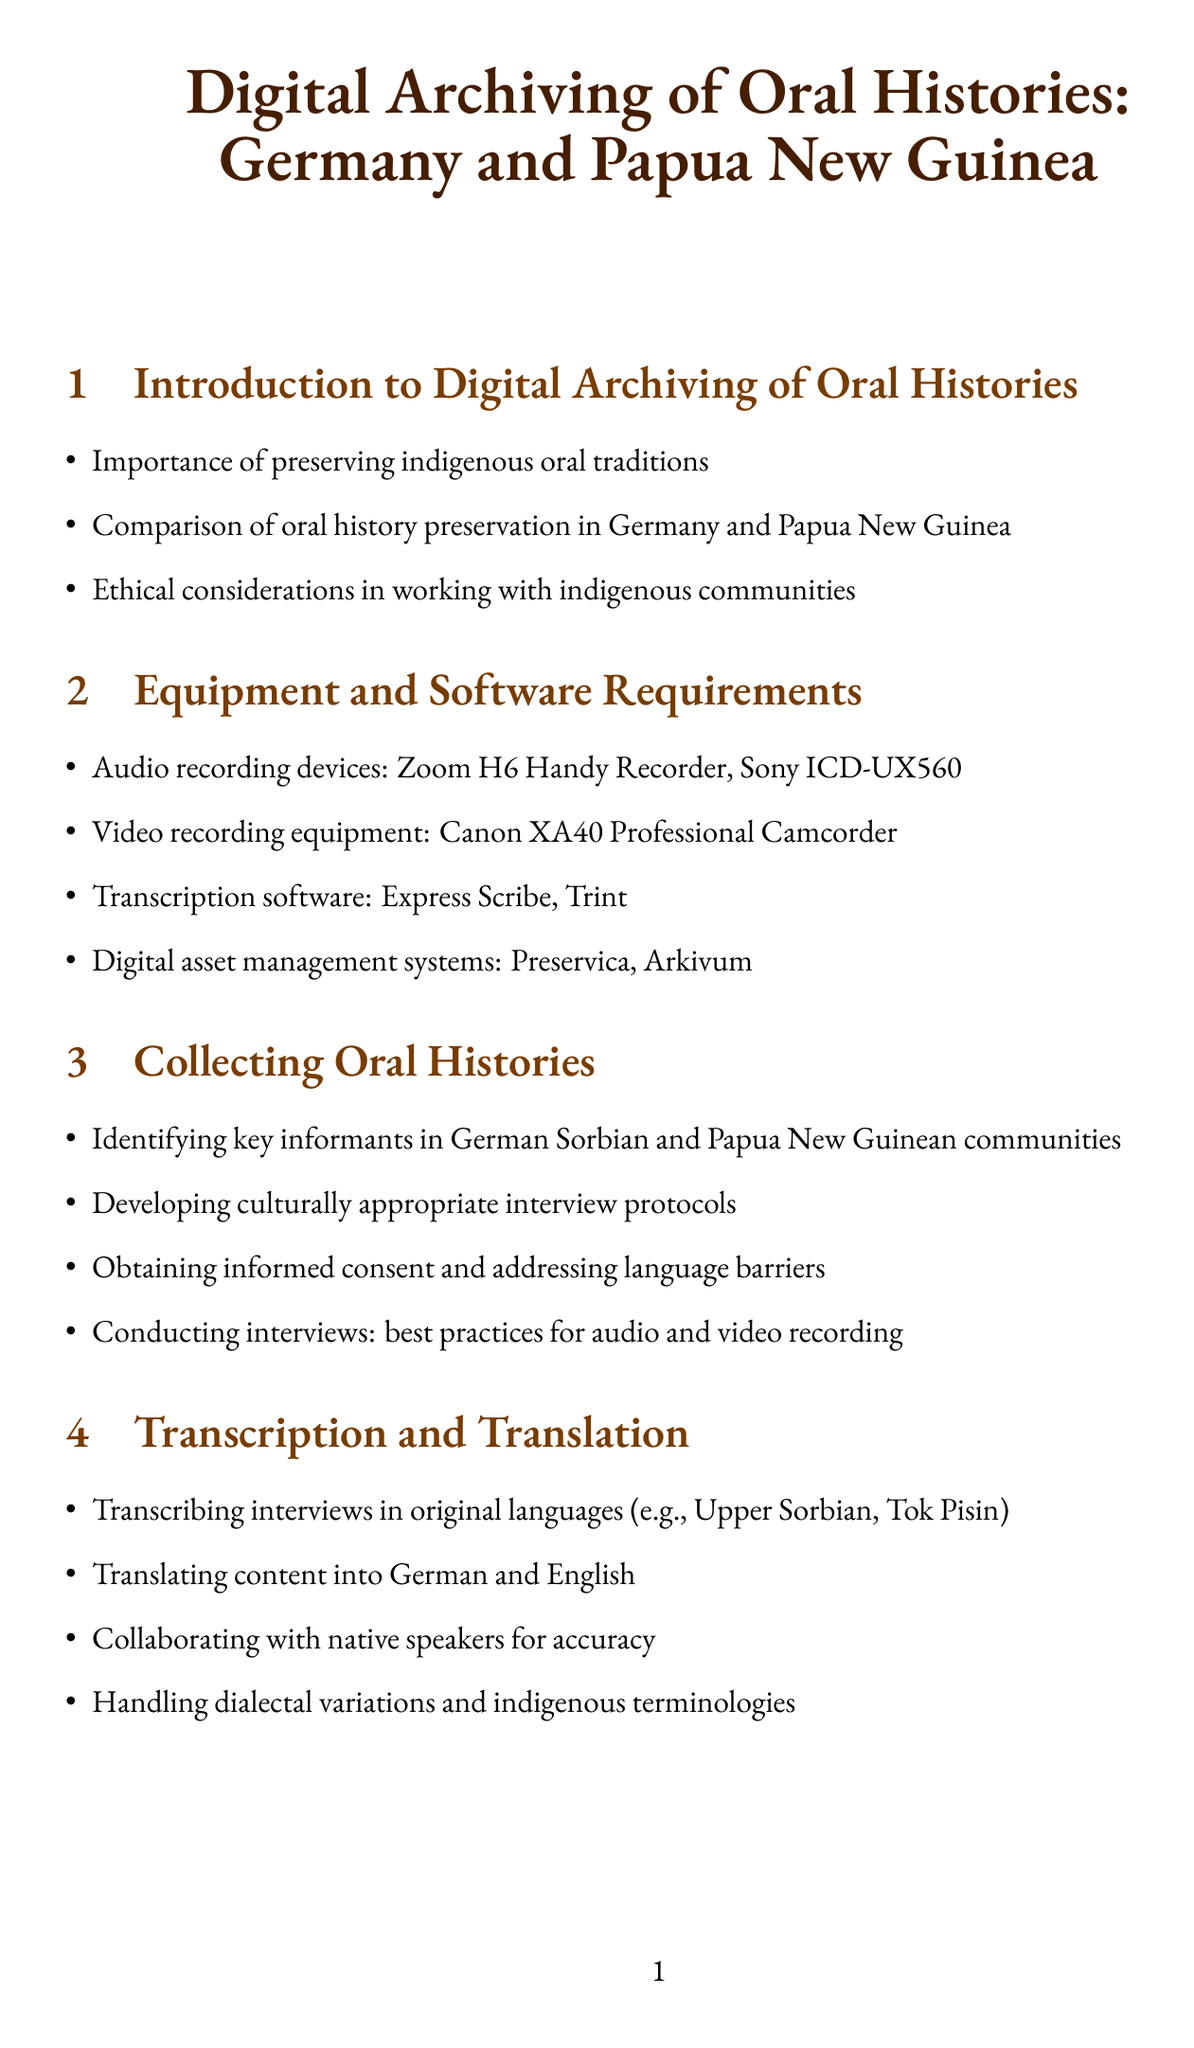what is the title of the manual? The title of the manual can be found at the beginning of the document and specifies the focus on digital archiving of oral histories in two specific countries.
Answer: Digital Archiving of Oral Histories: Germany and Papua New Guinea which audio recording device is mentioned first? The first audio recording device listed under equipment requirements in the document represents a specific choice for recording oral histories.
Answer: Zoom H6 Handy Recorder what is one software used for transcription? The document includes specific software options for transcription, highlighting tools available for processing recorded interviews.
Answer: Express Scribe what principle is mentioned for digital preservation strategies? The document refers to a widely recognized principle in digital preservation that emphasizes redundancy to safeguard digital content.
Answer: LOCKSS which two groups are mentioned for community engagement? The document lists specific partnerships that aim to enhance community engagement and capacity building in digital archiving practices.
Answer: Bautzener Sorben-Verein and University of Papua New Guinea how many sections are in the manual? The number of sections is an important aspect of the manual's structure, indicating its organization and subject coverage.
Answer: Ten what type of law is addressed in legal considerations? This section emphasizes understanding legal frameworks that can impact the process of archiving oral histories from indigenous communities.
Answer: Copyright law what storage solution is mentioned for digital preservation? A specific storage solution is recommended in the document, which is commonly used for secure and scalable digital storage.
Answer: Amazon S3 what is a consideration for organizing interviews? Certain considerations are addressed in the context of developing protocols for gathering oral histories, especially regarding cultural sensitivity.
Answer: Culturally appropriate interview protocols what is the aim of bilingual finding aids in cataloging? The goal of incorporating bilingual finding aids pertains to accessibility and usability of archived materials for diverse user groups.
Answer: Creating bilingual finding aids 